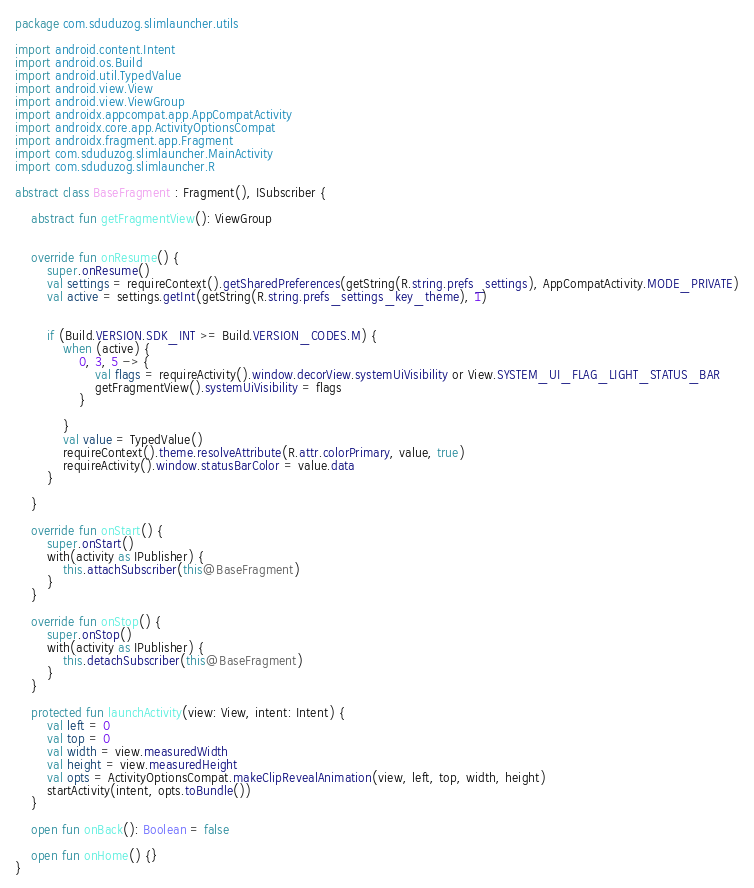<code> <loc_0><loc_0><loc_500><loc_500><_Kotlin_>package com.sduduzog.slimlauncher.utils

import android.content.Intent
import android.os.Build
import android.util.TypedValue
import android.view.View
import android.view.ViewGroup
import androidx.appcompat.app.AppCompatActivity
import androidx.core.app.ActivityOptionsCompat
import androidx.fragment.app.Fragment
import com.sduduzog.slimlauncher.MainActivity
import com.sduduzog.slimlauncher.R

abstract class BaseFragment : Fragment(), ISubscriber {

    abstract fun getFragmentView(): ViewGroup


    override fun onResume() {
        super.onResume()
        val settings = requireContext().getSharedPreferences(getString(R.string.prefs_settings), AppCompatActivity.MODE_PRIVATE)
        val active = settings.getInt(getString(R.string.prefs_settings_key_theme), 1)


        if (Build.VERSION.SDK_INT >= Build.VERSION_CODES.M) {
            when (active) {
                0, 3, 5 -> {
                    val flags = requireActivity().window.decorView.systemUiVisibility or View.SYSTEM_UI_FLAG_LIGHT_STATUS_BAR
                    getFragmentView().systemUiVisibility = flags
                }

            }
            val value = TypedValue()
            requireContext().theme.resolveAttribute(R.attr.colorPrimary, value, true)
            requireActivity().window.statusBarColor = value.data
        }

    }

    override fun onStart() {
        super.onStart()
        with(activity as IPublisher) {
            this.attachSubscriber(this@BaseFragment)
        }
    }

    override fun onStop() {
        super.onStop()
        with(activity as IPublisher) {
            this.detachSubscriber(this@BaseFragment)
        }
    }

    protected fun launchActivity(view: View, intent: Intent) {
        val left = 0
        val top = 0
        val width = view.measuredWidth
        val height = view.measuredHeight
        val opts = ActivityOptionsCompat.makeClipRevealAnimation(view, left, top, width, height)
        startActivity(intent, opts.toBundle())
    }

    open fun onBack(): Boolean = false

    open fun onHome() {}
}
</code> 